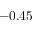Convert formula to latex. <formula><loc_0><loc_0><loc_500><loc_500>- 0 . 4 5</formula> 